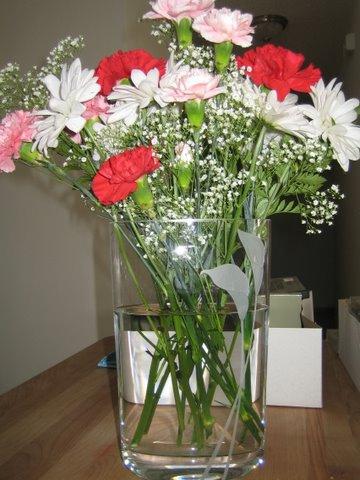Is the vase sitting on a metal table?
Quick response, please. No. What color are the flowers in the vase?
Be succinct. Red pink and white. Is there water in the vase?
Concise answer only. Yes. What color flowers in the vase?
Answer briefly. Red, pink, white. Is this a large bouquet?
Be succinct. Yes. Is the vase clear?
Quick response, please. Yes. 